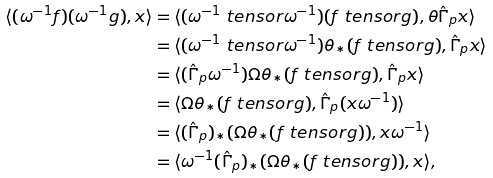Convert formula to latex. <formula><loc_0><loc_0><loc_500><loc_500>\langle ( \omega ^ { - 1 } f ) ( \omega ^ { - 1 } g ) , x \rangle & = \langle ( \omega ^ { - 1 } \ t e n s o r \omega ^ { - 1 } ) ( f \ t e n s o r g ) , \theta \hat { \Gamma } _ { p } x \rangle \\ & = \langle ( \omega ^ { - 1 } \ t e n s o r \omega ^ { - 1 } ) \theta _ { \ast } ( f \ t e n s o r g ) , \hat { \Gamma } _ { p } x \rangle \\ & = \langle ( \hat { \Gamma } _ { p } \omega ^ { - 1 } ) \Omega \theta _ { \ast } ( f \ t e n s o r g ) , \hat { \Gamma } _ { p } x \rangle \\ & = \langle \Omega \theta _ { \ast } ( f \ t e n s o r g ) , \hat { \Gamma } _ { p } ( x \omega ^ { - 1 } ) \rangle \\ & = \langle ( \hat { \Gamma } _ { p } ) _ { \ast } ( \Omega \theta _ { \ast } ( f \ t e n s o r g ) ) , x \omega ^ { - 1 } \rangle \\ & = \langle \omega ^ { - 1 } ( \hat { \Gamma } _ { p } ) _ { \ast } ( \Omega \theta _ { \ast } ( f \ t e n s o r g ) ) , x \rangle ,</formula> 